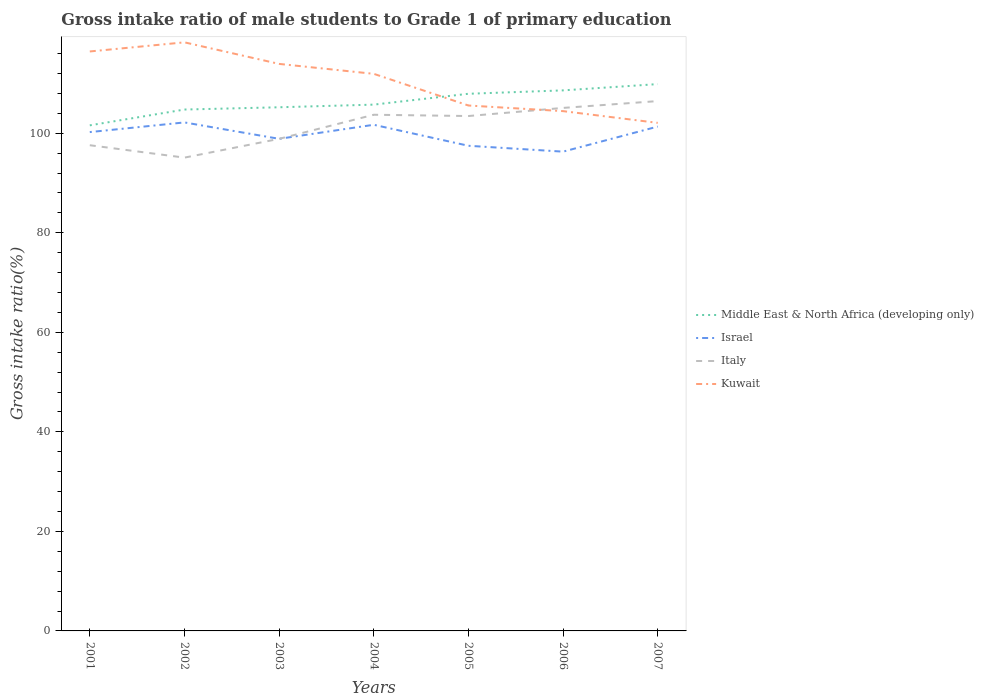How many different coloured lines are there?
Your answer should be very brief. 4. Across all years, what is the maximum gross intake ratio in Middle East & North Africa (developing only)?
Provide a short and direct response. 101.59. What is the total gross intake ratio in Kuwait in the graph?
Offer a terse response. 7.49. What is the difference between the highest and the second highest gross intake ratio in Italy?
Provide a succinct answer. 11.36. Is the gross intake ratio in Italy strictly greater than the gross intake ratio in Middle East & North Africa (developing only) over the years?
Your response must be concise. Yes. What is the difference between two consecutive major ticks on the Y-axis?
Your response must be concise. 20. How many legend labels are there?
Give a very brief answer. 4. How are the legend labels stacked?
Your response must be concise. Vertical. What is the title of the graph?
Keep it short and to the point. Gross intake ratio of male students to Grade 1 of primary education. What is the label or title of the X-axis?
Give a very brief answer. Years. What is the label or title of the Y-axis?
Keep it short and to the point. Gross intake ratio(%). What is the Gross intake ratio(%) in Middle East & North Africa (developing only) in 2001?
Keep it short and to the point. 101.59. What is the Gross intake ratio(%) of Israel in 2001?
Provide a succinct answer. 100.23. What is the Gross intake ratio(%) of Italy in 2001?
Provide a succinct answer. 97.59. What is the Gross intake ratio(%) in Kuwait in 2001?
Ensure brevity in your answer.  116.43. What is the Gross intake ratio(%) of Middle East & North Africa (developing only) in 2002?
Your response must be concise. 104.76. What is the Gross intake ratio(%) in Israel in 2002?
Offer a very short reply. 102.17. What is the Gross intake ratio(%) of Italy in 2002?
Your answer should be very brief. 95.1. What is the Gross intake ratio(%) in Kuwait in 2002?
Your answer should be compact. 118.26. What is the Gross intake ratio(%) of Middle East & North Africa (developing only) in 2003?
Provide a short and direct response. 105.22. What is the Gross intake ratio(%) in Israel in 2003?
Provide a short and direct response. 98.88. What is the Gross intake ratio(%) in Italy in 2003?
Ensure brevity in your answer.  98.87. What is the Gross intake ratio(%) in Kuwait in 2003?
Offer a terse response. 113.93. What is the Gross intake ratio(%) in Middle East & North Africa (developing only) in 2004?
Keep it short and to the point. 105.75. What is the Gross intake ratio(%) of Israel in 2004?
Your answer should be compact. 101.7. What is the Gross intake ratio(%) in Italy in 2004?
Offer a terse response. 103.72. What is the Gross intake ratio(%) in Kuwait in 2004?
Make the answer very short. 111.94. What is the Gross intake ratio(%) of Middle East & North Africa (developing only) in 2005?
Ensure brevity in your answer.  107.93. What is the Gross intake ratio(%) of Israel in 2005?
Give a very brief answer. 97.48. What is the Gross intake ratio(%) of Italy in 2005?
Ensure brevity in your answer.  103.46. What is the Gross intake ratio(%) of Kuwait in 2005?
Ensure brevity in your answer.  105.57. What is the Gross intake ratio(%) of Middle East & North Africa (developing only) in 2006?
Your answer should be very brief. 108.61. What is the Gross intake ratio(%) in Israel in 2006?
Give a very brief answer. 96.3. What is the Gross intake ratio(%) in Italy in 2006?
Your answer should be compact. 105.09. What is the Gross intake ratio(%) in Kuwait in 2006?
Provide a short and direct response. 104.44. What is the Gross intake ratio(%) of Middle East & North Africa (developing only) in 2007?
Keep it short and to the point. 109.87. What is the Gross intake ratio(%) in Israel in 2007?
Your response must be concise. 101.34. What is the Gross intake ratio(%) in Italy in 2007?
Give a very brief answer. 106.46. What is the Gross intake ratio(%) in Kuwait in 2007?
Provide a short and direct response. 102.08. Across all years, what is the maximum Gross intake ratio(%) in Middle East & North Africa (developing only)?
Make the answer very short. 109.87. Across all years, what is the maximum Gross intake ratio(%) in Israel?
Provide a succinct answer. 102.17. Across all years, what is the maximum Gross intake ratio(%) of Italy?
Your answer should be compact. 106.46. Across all years, what is the maximum Gross intake ratio(%) in Kuwait?
Give a very brief answer. 118.26. Across all years, what is the minimum Gross intake ratio(%) in Middle East & North Africa (developing only)?
Your answer should be very brief. 101.59. Across all years, what is the minimum Gross intake ratio(%) in Israel?
Keep it short and to the point. 96.3. Across all years, what is the minimum Gross intake ratio(%) in Italy?
Your answer should be compact. 95.1. Across all years, what is the minimum Gross intake ratio(%) of Kuwait?
Offer a very short reply. 102.08. What is the total Gross intake ratio(%) in Middle East & North Africa (developing only) in the graph?
Keep it short and to the point. 743.73. What is the total Gross intake ratio(%) of Israel in the graph?
Provide a succinct answer. 698.11. What is the total Gross intake ratio(%) in Italy in the graph?
Offer a very short reply. 710.29. What is the total Gross intake ratio(%) of Kuwait in the graph?
Offer a very short reply. 772.67. What is the difference between the Gross intake ratio(%) of Middle East & North Africa (developing only) in 2001 and that in 2002?
Give a very brief answer. -3.18. What is the difference between the Gross intake ratio(%) in Israel in 2001 and that in 2002?
Your response must be concise. -1.94. What is the difference between the Gross intake ratio(%) in Italy in 2001 and that in 2002?
Make the answer very short. 2.49. What is the difference between the Gross intake ratio(%) of Kuwait in 2001 and that in 2002?
Offer a terse response. -1.83. What is the difference between the Gross intake ratio(%) of Middle East & North Africa (developing only) in 2001 and that in 2003?
Provide a short and direct response. -3.63. What is the difference between the Gross intake ratio(%) in Israel in 2001 and that in 2003?
Your response must be concise. 1.35. What is the difference between the Gross intake ratio(%) of Italy in 2001 and that in 2003?
Offer a very short reply. -1.28. What is the difference between the Gross intake ratio(%) of Kuwait in 2001 and that in 2003?
Make the answer very short. 2.5. What is the difference between the Gross intake ratio(%) of Middle East & North Africa (developing only) in 2001 and that in 2004?
Your answer should be very brief. -4.16. What is the difference between the Gross intake ratio(%) of Israel in 2001 and that in 2004?
Offer a terse response. -1.47. What is the difference between the Gross intake ratio(%) of Italy in 2001 and that in 2004?
Make the answer very short. -6.12. What is the difference between the Gross intake ratio(%) of Kuwait in 2001 and that in 2004?
Provide a succinct answer. 4.5. What is the difference between the Gross intake ratio(%) in Middle East & North Africa (developing only) in 2001 and that in 2005?
Your response must be concise. -6.34. What is the difference between the Gross intake ratio(%) of Israel in 2001 and that in 2005?
Provide a succinct answer. 2.75. What is the difference between the Gross intake ratio(%) in Italy in 2001 and that in 2005?
Keep it short and to the point. -5.86. What is the difference between the Gross intake ratio(%) in Kuwait in 2001 and that in 2005?
Offer a very short reply. 10.86. What is the difference between the Gross intake ratio(%) in Middle East & North Africa (developing only) in 2001 and that in 2006?
Ensure brevity in your answer.  -7.03. What is the difference between the Gross intake ratio(%) of Israel in 2001 and that in 2006?
Your response must be concise. 3.93. What is the difference between the Gross intake ratio(%) of Italy in 2001 and that in 2006?
Make the answer very short. -7.5. What is the difference between the Gross intake ratio(%) of Kuwait in 2001 and that in 2006?
Your answer should be compact. 11.99. What is the difference between the Gross intake ratio(%) of Middle East & North Africa (developing only) in 2001 and that in 2007?
Ensure brevity in your answer.  -8.29. What is the difference between the Gross intake ratio(%) of Israel in 2001 and that in 2007?
Make the answer very short. -1.11. What is the difference between the Gross intake ratio(%) of Italy in 2001 and that in 2007?
Provide a succinct answer. -8.87. What is the difference between the Gross intake ratio(%) in Kuwait in 2001 and that in 2007?
Provide a succinct answer. 14.35. What is the difference between the Gross intake ratio(%) in Middle East & North Africa (developing only) in 2002 and that in 2003?
Your answer should be compact. -0.46. What is the difference between the Gross intake ratio(%) in Israel in 2002 and that in 2003?
Give a very brief answer. 3.29. What is the difference between the Gross intake ratio(%) in Italy in 2002 and that in 2003?
Give a very brief answer. -3.77. What is the difference between the Gross intake ratio(%) in Kuwait in 2002 and that in 2003?
Your answer should be compact. 4.33. What is the difference between the Gross intake ratio(%) in Middle East & North Africa (developing only) in 2002 and that in 2004?
Provide a short and direct response. -0.99. What is the difference between the Gross intake ratio(%) in Israel in 2002 and that in 2004?
Keep it short and to the point. 0.47. What is the difference between the Gross intake ratio(%) of Italy in 2002 and that in 2004?
Offer a terse response. -8.62. What is the difference between the Gross intake ratio(%) of Kuwait in 2002 and that in 2004?
Make the answer very short. 6.33. What is the difference between the Gross intake ratio(%) in Middle East & North Africa (developing only) in 2002 and that in 2005?
Ensure brevity in your answer.  -3.17. What is the difference between the Gross intake ratio(%) of Israel in 2002 and that in 2005?
Provide a succinct answer. 4.69. What is the difference between the Gross intake ratio(%) of Italy in 2002 and that in 2005?
Keep it short and to the point. -8.36. What is the difference between the Gross intake ratio(%) in Kuwait in 2002 and that in 2005?
Your answer should be compact. 12.69. What is the difference between the Gross intake ratio(%) in Middle East & North Africa (developing only) in 2002 and that in 2006?
Provide a short and direct response. -3.85. What is the difference between the Gross intake ratio(%) in Israel in 2002 and that in 2006?
Your response must be concise. 5.87. What is the difference between the Gross intake ratio(%) in Italy in 2002 and that in 2006?
Ensure brevity in your answer.  -9.99. What is the difference between the Gross intake ratio(%) of Kuwait in 2002 and that in 2006?
Make the answer very short. 13.82. What is the difference between the Gross intake ratio(%) in Middle East & North Africa (developing only) in 2002 and that in 2007?
Give a very brief answer. -5.11. What is the difference between the Gross intake ratio(%) of Israel in 2002 and that in 2007?
Ensure brevity in your answer.  0.83. What is the difference between the Gross intake ratio(%) of Italy in 2002 and that in 2007?
Provide a short and direct response. -11.36. What is the difference between the Gross intake ratio(%) in Kuwait in 2002 and that in 2007?
Ensure brevity in your answer.  16.18. What is the difference between the Gross intake ratio(%) in Middle East & North Africa (developing only) in 2003 and that in 2004?
Your answer should be very brief. -0.53. What is the difference between the Gross intake ratio(%) of Israel in 2003 and that in 2004?
Your answer should be compact. -2.82. What is the difference between the Gross intake ratio(%) of Italy in 2003 and that in 2004?
Offer a terse response. -4.84. What is the difference between the Gross intake ratio(%) in Kuwait in 2003 and that in 2004?
Offer a very short reply. 2. What is the difference between the Gross intake ratio(%) in Middle East & North Africa (developing only) in 2003 and that in 2005?
Your response must be concise. -2.71. What is the difference between the Gross intake ratio(%) of Israel in 2003 and that in 2005?
Your answer should be compact. 1.4. What is the difference between the Gross intake ratio(%) of Italy in 2003 and that in 2005?
Provide a short and direct response. -4.59. What is the difference between the Gross intake ratio(%) in Kuwait in 2003 and that in 2005?
Provide a succinct answer. 8.36. What is the difference between the Gross intake ratio(%) of Middle East & North Africa (developing only) in 2003 and that in 2006?
Give a very brief answer. -3.39. What is the difference between the Gross intake ratio(%) of Israel in 2003 and that in 2006?
Your answer should be very brief. 2.58. What is the difference between the Gross intake ratio(%) in Italy in 2003 and that in 2006?
Keep it short and to the point. -6.22. What is the difference between the Gross intake ratio(%) of Kuwait in 2003 and that in 2006?
Ensure brevity in your answer.  9.49. What is the difference between the Gross intake ratio(%) in Middle East & North Africa (developing only) in 2003 and that in 2007?
Provide a succinct answer. -4.66. What is the difference between the Gross intake ratio(%) of Israel in 2003 and that in 2007?
Your answer should be compact. -2.46. What is the difference between the Gross intake ratio(%) of Italy in 2003 and that in 2007?
Your answer should be very brief. -7.59. What is the difference between the Gross intake ratio(%) in Kuwait in 2003 and that in 2007?
Provide a succinct answer. 11.85. What is the difference between the Gross intake ratio(%) of Middle East & North Africa (developing only) in 2004 and that in 2005?
Give a very brief answer. -2.18. What is the difference between the Gross intake ratio(%) in Israel in 2004 and that in 2005?
Your response must be concise. 4.22. What is the difference between the Gross intake ratio(%) in Italy in 2004 and that in 2005?
Give a very brief answer. 0.26. What is the difference between the Gross intake ratio(%) in Kuwait in 2004 and that in 2005?
Offer a terse response. 6.36. What is the difference between the Gross intake ratio(%) of Middle East & North Africa (developing only) in 2004 and that in 2006?
Offer a very short reply. -2.86. What is the difference between the Gross intake ratio(%) of Israel in 2004 and that in 2006?
Offer a terse response. 5.4. What is the difference between the Gross intake ratio(%) in Italy in 2004 and that in 2006?
Make the answer very short. -1.37. What is the difference between the Gross intake ratio(%) of Kuwait in 2004 and that in 2006?
Provide a succinct answer. 7.49. What is the difference between the Gross intake ratio(%) of Middle East & North Africa (developing only) in 2004 and that in 2007?
Provide a succinct answer. -4.12. What is the difference between the Gross intake ratio(%) of Israel in 2004 and that in 2007?
Your answer should be very brief. 0.36. What is the difference between the Gross intake ratio(%) in Italy in 2004 and that in 2007?
Keep it short and to the point. -2.75. What is the difference between the Gross intake ratio(%) of Kuwait in 2004 and that in 2007?
Make the answer very short. 9.85. What is the difference between the Gross intake ratio(%) of Middle East & North Africa (developing only) in 2005 and that in 2006?
Your answer should be very brief. -0.68. What is the difference between the Gross intake ratio(%) of Israel in 2005 and that in 2006?
Keep it short and to the point. 1.18. What is the difference between the Gross intake ratio(%) of Italy in 2005 and that in 2006?
Provide a succinct answer. -1.63. What is the difference between the Gross intake ratio(%) of Kuwait in 2005 and that in 2006?
Make the answer very short. 1.13. What is the difference between the Gross intake ratio(%) in Middle East & North Africa (developing only) in 2005 and that in 2007?
Offer a very short reply. -1.94. What is the difference between the Gross intake ratio(%) of Israel in 2005 and that in 2007?
Make the answer very short. -3.86. What is the difference between the Gross intake ratio(%) of Italy in 2005 and that in 2007?
Your response must be concise. -3. What is the difference between the Gross intake ratio(%) in Kuwait in 2005 and that in 2007?
Ensure brevity in your answer.  3.49. What is the difference between the Gross intake ratio(%) of Middle East & North Africa (developing only) in 2006 and that in 2007?
Provide a short and direct response. -1.26. What is the difference between the Gross intake ratio(%) in Israel in 2006 and that in 2007?
Keep it short and to the point. -5.04. What is the difference between the Gross intake ratio(%) of Italy in 2006 and that in 2007?
Offer a terse response. -1.37. What is the difference between the Gross intake ratio(%) of Kuwait in 2006 and that in 2007?
Provide a short and direct response. 2.36. What is the difference between the Gross intake ratio(%) of Middle East & North Africa (developing only) in 2001 and the Gross intake ratio(%) of Israel in 2002?
Your answer should be compact. -0.59. What is the difference between the Gross intake ratio(%) of Middle East & North Africa (developing only) in 2001 and the Gross intake ratio(%) of Italy in 2002?
Provide a succinct answer. 6.49. What is the difference between the Gross intake ratio(%) in Middle East & North Africa (developing only) in 2001 and the Gross intake ratio(%) in Kuwait in 2002?
Your answer should be very brief. -16.68. What is the difference between the Gross intake ratio(%) of Israel in 2001 and the Gross intake ratio(%) of Italy in 2002?
Keep it short and to the point. 5.13. What is the difference between the Gross intake ratio(%) in Israel in 2001 and the Gross intake ratio(%) in Kuwait in 2002?
Offer a very short reply. -18.03. What is the difference between the Gross intake ratio(%) of Italy in 2001 and the Gross intake ratio(%) of Kuwait in 2002?
Your response must be concise. -20.67. What is the difference between the Gross intake ratio(%) in Middle East & North Africa (developing only) in 2001 and the Gross intake ratio(%) in Israel in 2003?
Offer a very short reply. 2.71. What is the difference between the Gross intake ratio(%) of Middle East & North Africa (developing only) in 2001 and the Gross intake ratio(%) of Italy in 2003?
Make the answer very short. 2.72. What is the difference between the Gross intake ratio(%) of Middle East & North Africa (developing only) in 2001 and the Gross intake ratio(%) of Kuwait in 2003?
Your answer should be very brief. -12.35. What is the difference between the Gross intake ratio(%) in Israel in 2001 and the Gross intake ratio(%) in Italy in 2003?
Your response must be concise. 1.36. What is the difference between the Gross intake ratio(%) in Israel in 2001 and the Gross intake ratio(%) in Kuwait in 2003?
Offer a very short reply. -13.7. What is the difference between the Gross intake ratio(%) in Italy in 2001 and the Gross intake ratio(%) in Kuwait in 2003?
Provide a succinct answer. -16.34. What is the difference between the Gross intake ratio(%) of Middle East & North Africa (developing only) in 2001 and the Gross intake ratio(%) of Israel in 2004?
Provide a short and direct response. -0.11. What is the difference between the Gross intake ratio(%) in Middle East & North Africa (developing only) in 2001 and the Gross intake ratio(%) in Italy in 2004?
Provide a succinct answer. -2.13. What is the difference between the Gross intake ratio(%) in Middle East & North Africa (developing only) in 2001 and the Gross intake ratio(%) in Kuwait in 2004?
Your answer should be compact. -10.35. What is the difference between the Gross intake ratio(%) in Israel in 2001 and the Gross intake ratio(%) in Italy in 2004?
Your answer should be compact. -3.48. What is the difference between the Gross intake ratio(%) in Israel in 2001 and the Gross intake ratio(%) in Kuwait in 2004?
Your answer should be very brief. -11.7. What is the difference between the Gross intake ratio(%) in Italy in 2001 and the Gross intake ratio(%) in Kuwait in 2004?
Ensure brevity in your answer.  -14.34. What is the difference between the Gross intake ratio(%) of Middle East & North Africa (developing only) in 2001 and the Gross intake ratio(%) of Israel in 2005?
Make the answer very short. 4.1. What is the difference between the Gross intake ratio(%) of Middle East & North Africa (developing only) in 2001 and the Gross intake ratio(%) of Italy in 2005?
Your answer should be very brief. -1.87. What is the difference between the Gross intake ratio(%) of Middle East & North Africa (developing only) in 2001 and the Gross intake ratio(%) of Kuwait in 2005?
Ensure brevity in your answer.  -3.99. What is the difference between the Gross intake ratio(%) of Israel in 2001 and the Gross intake ratio(%) of Italy in 2005?
Your answer should be compact. -3.23. What is the difference between the Gross intake ratio(%) of Israel in 2001 and the Gross intake ratio(%) of Kuwait in 2005?
Give a very brief answer. -5.34. What is the difference between the Gross intake ratio(%) in Italy in 2001 and the Gross intake ratio(%) in Kuwait in 2005?
Make the answer very short. -7.98. What is the difference between the Gross intake ratio(%) in Middle East & North Africa (developing only) in 2001 and the Gross intake ratio(%) in Israel in 2006?
Your answer should be very brief. 5.29. What is the difference between the Gross intake ratio(%) of Middle East & North Africa (developing only) in 2001 and the Gross intake ratio(%) of Italy in 2006?
Your response must be concise. -3.5. What is the difference between the Gross intake ratio(%) in Middle East & North Africa (developing only) in 2001 and the Gross intake ratio(%) in Kuwait in 2006?
Offer a terse response. -2.85. What is the difference between the Gross intake ratio(%) of Israel in 2001 and the Gross intake ratio(%) of Italy in 2006?
Your answer should be compact. -4.86. What is the difference between the Gross intake ratio(%) of Israel in 2001 and the Gross intake ratio(%) of Kuwait in 2006?
Ensure brevity in your answer.  -4.21. What is the difference between the Gross intake ratio(%) in Italy in 2001 and the Gross intake ratio(%) in Kuwait in 2006?
Offer a terse response. -6.85. What is the difference between the Gross intake ratio(%) in Middle East & North Africa (developing only) in 2001 and the Gross intake ratio(%) in Israel in 2007?
Your answer should be compact. 0.24. What is the difference between the Gross intake ratio(%) in Middle East & North Africa (developing only) in 2001 and the Gross intake ratio(%) in Italy in 2007?
Provide a short and direct response. -4.87. What is the difference between the Gross intake ratio(%) in Middle East & North Africa (developing only) in 2001 and the Gross intake ratio(%) in Kuwait in 2007?
Offer a very short reply. -0.5. What is the difference between the Gross intake ratio(%) in Israel in 2001 and the Gross intake ratio(%) in Italy in 2007?
Your answer should be very brief. -6.23. What is the difference between the Gross intake ratio(%) of Israel in 2001 and the Gross intake ratio(%) of Kuwait in 2007?
Make the answer very short. -1.85. What is the difference between the Gross intake ratio(%) in Italy in 2001 and the Gross intake ratio(%) in Kuwait in 2007?
Give a very brief answer. -4.49. What is the difference between the Gross intake ratio(%) in Middle East & North Africa (developing only) in 2002 and the Gross intake ratio(%) in Israel in 2003?
Offer a very short reply. 5.88. What is the difference between the Gross intake ratio(%) of Middle East & North Africa (developing only) in 2002 and the Gross intake ratio(%) of Italy in 2003?
Make the answer very short. 5.89. What is the difference between the Gross intake ratio(%) of Middle East & North Africa (developing only) in 2002 and the Gross intake ratio(%) of Kuwait in 2003?
Provide a succinct answer. -9.17. What is the difference between the Gross intake ratio(%) of Israel in 2002 and the Gross intake ratio(%) of Italy in 2003?
Give a very brief answer. 3.3. What is the difference between the Gross intake ratio(%) of Israel in 2002 and the Gross intake ratio(%) of Kuwait in 2003?
Offer a very short reply. -11.76. What is the difference between the Gross intake ratio(%) of Italy in 2002 and the Gross intake ratio(%) of Kuwait in 2003?
Ensure brevity in your answer.  -18.83. What is the difference between the Gross intake ratio(%) in Middle East & North Africa (developing only) in 2002 and the Gross intake ratio(%) in Israel in 2004?
Offer a very short reply. 3.06. What is the difference between the Gross intake ratio(%) of Middle East & North Africa (developing only) in 2002 and the Gross intake ratio(%) of Italy in 2004?
Your answer should be very brief. 1.05. What is the difference between the Gross intake ratio(%) of Middle East & North Africa (developing only) in 2002 and the Gross intake ratio(%) of Kuwait in 2004?
Give a very brief answer. -7.17. What is the difference between the Gross intake ratio(%) in Israel in 2002 and the Gross intake ratio(%) in Italy in 2004?
Ensure brevity in your answer.  -1.54. What is the difference between the Gross intake ratio(%) in Israel in 2002 and the Gross intake ratio(%) in Kuwait in 2004?
Provide a short and direct response. -9.76. What is the difference between the Gross intake ratio(%) in Italy in 2002 and the Gross intake ratio(%) in Kuwait in 2004?
Provide a succinct answer. -16.84. What is the difference between the Gross intake ratio(%) in Middle East & North Africa (developing only) in 2002 and the Gross intake ratio(%) in Israel in 2005?
Ensure brevity in your answer.  7.28. What is the difference between the Gross intake ratio(%) of Middle East & North Africa (developing only) in 2002 and the Gross intake ratio(%) of Italy in 2005?
Make the answer very short. 1.31. What is the difference between the Gross intake ratio(%) of Middle East & North Africa (developing only) in 2002 and the Gross intake ratio(%) of Kuwait in 2005?
Your answer should be compact. -0.81. What is the difference between the Gross intake ratio(%) of Israel in 2002 and the Gross intake ratio(%) of Italy in 2005?
Your answer should be very brief. -1.28. What is the difference between the Gross intake ratio(%) of Israel in 2002 and the Gross intake ratio(%) of Kuwait in 2005?
Keep it short and to the point. -3.4. What is the difference between the Gross intake ratio(%) of Italy in 2002 and the Gross intake ratio(%) of Kuwait in 2005?
Keep it short and to the point. -10.47. What is the difference between the Gross intake ratio(%) in Middle East & North Africa (developing only) in 2002 and the Gross intake ratio(%) in Israel in 2006?
Offer a very short reply. 8.46. What is the difference between the Gross intake ratio(%) of Middle East & North Africa (developing only) in 2002 and the Gross intake ratio(%) of Italy in 2006?
Provide a succinct answer. -0.33. What is the difference between the Gross intake ratio(%) in Middle East & North Africa (developing only) in 2002 and the Gross intake ratio(%) in Kuwait in 2006?
Your response must be concise. 0.32. What is the difference between the Gross intake ratio(%) in Israel in 2002 and the Gross intake ratio(%) in Italy in 2006?
Offer a terse response. -2.92. What is the difference between the Gross intake ratio(%) in Israel in 2002 and the Gross intake ratio(%) in Kuwait in 2006?
Provide a short and direct response. -2.27. What is the difference between the Gross intake ratio(%) of Italy in 2002 and the Gross intake ratio(%) of Kuwait in 2006?
Offer a terse response. -9.34. What is the difference between the Gross intake ratio(%) in Middle East & North Africa (developing only) in 2002 and the Gross intake ratio(%) in Israel in 2007?
Provide a short and direct response. 3.42. What is the difference between the Gross intake ratio(%) of Middle East & North Africa (developing only) in 2002 and the Gross intake ratio(%) of Italy in 2007?
Provide a succinct answer. -1.7. What is the difference between the Gross intake ratio(%) of Middle East & North Africa (developing only) in 2002 and the Gross intake ratio(%) of Kuwait in 2007?
Ensure brevity in your answer.  2.68. What is the difference between the Gross intake ratio(%) of Israel in 2002 and the Gross intake ratio(%) of Italy in 2007?
Keep it short and to the point. -4.29. What is the difference between the Gross intake ratio(%) of Israel in 2002 and the Gross intake ratio(%) of Kuwait in 2007?
Make the answer very short. 0.09. What is the difference between the Gross intake ratio(%) of Italy in 2002 and the Gross intake ratio(%) of Kuwait in 2007?
Provide a succinct answer. -6.98. What is the difference between the Gross intake ratio(%) in Middle East & North Africa (developing only) in 2003 and the Gross intake ratio(%) in Israel in 2004?
Your answer should be compact. 3.52. What is the difference between the Gross intake ratio(%) of Middle East & North Africa (developing only) in 2003 and the Gross intake ratio(%) of Italy in 2004?
Offer a terse response. 1.5. What is the difference between the Gross intake ratio(%) in Middle East & North Africa (developing only) in 2003 and the Gross intake ratio(%) in Kuwait in 2004?
Keep it short and to the point. -6.72. What is the difference between the Gross intake ratio(%) of Israel in 2003 and the Gross intake ratio(%) of Italy in 2004?
Ensure brevity in your answer.  -4.84. What is the difference between the Gross intake ratio(%) of Israel in 2003 and the Gross intake ratio(%) of Kuwait in 2004?
Provide a succinct answer. -13.06. What is the difference between the Gross intake ratio(%) in Italy in 2003 and the Gross intake ratio(%) in Kuwait in 2004?
Keep it short and to the point. -13.06. What is the difference between the Gross intake ratio(%) of Middle East & North Africa (developing only) in 2003 and the Gross intake ratio(%) of Israel in 2005?
Offer a terse response. 7.74. What is the difference between the Gross intake ratio(%) in Middle East & North Africa (developing only) in 2003 and the Gross intake ratio(%) in Italy in 2005?
Give a very brief answer. 1.76. What is the difference between the Gross intake ratio(%) in Middle East & North Africa (developing only) in 2003 and the Gross intake ratio(%) in Kuwait in 2005?
Ensure brevity in your answer.  -0.36. What is the difference between the Gross intake ratio(%) in Israel in 2003 and the Gross intake ratio(%) in Italy in 2005?
Keep it short and to the point. -4.58. What is the difference between the Gross intake ratio(%) of Israel in 2003 and the Gross intake ratio(%) of Kuwait in 2005?
Give a very brief answer. -6.69. What is the difference between the Gross intake ratio(%) of Italy in 2003 and the Gross intake ratio(%) of Kuwait in 2005?
Ensure brevity in your answer.  -6.7. What is the difference between the Gross intake ratio(%) in Middle East & North Africa (developing only) in 2003 and the Gross intake ratio(%) in Israel in 2006?
Ensure brevity in your answer.  8.92. What is the difference between the Gross intake ratio(%) in Middle East & North Africa (developing only) in 2003 and the Gross intake ratio(%) in Italy in 2006?
Keep it short and to the point. 0.13. What is the difference between the Gross intake ratio(%) of Middle East & North Africa (developing only) in 2003 and the Gross intake ratio(%) of Kuwait in 2006?
Offer a very short reply. 0.78. What is the difference between the Gross intake ratio(%) of Israel in 2003 and the Gross intake ratio(%) of Italy in 2006?
Your answer should be very brief. -6.21. What is the difference between the Gross intake ratio(%) of Israel in 2003 and the Gross intake ratio(%) of Kuwait in 2006?
Offer a very short reply. -5.56. What is the difference between the Gross intake ratio(%) of Italy in 2003 and the Gross intake ratio(%) of Kuwait in 2006?
Your answer should be very brief. -5.57. What is the difference between the Gross intake ratio(%) of Middle East & North Africa (developing only) in 2003 and the Gross intake ratio(%) of Israel in 2007?
Your answer should be compact. 3.87. What is the difference between the Gross intake ratio(%) in Middle East & North Africa (developing only) in 2003 and the Gross intake ratio(%) in Italy in 2007?
Offer a very short reply. -1.24. What is the difference between the Gross intake ratio(%) in Middle East & North Africa (developing only) in 2003 and the Gross intake ratio(%) in Kuwait in 2007?
Your response must be concise. 3.13. What is the difference between the Gross intake ratio(%) in Israel in 2003 and the Gross intake ratio(%) in Italy in 2007?
Your response must be concise. -7.58. What is the difference between the Gross intake ratio(%) in Israel in 2003 and the Gross intake ratio(%) in Kuwait in 2007?
Make the answer very short. -3.21. What is the difference between the Gross intake ratio(%) in Italy in 2003 and the Gross intake ratio(%) in Kuwait in 2007?
Your response must be concise. -3.21. What is the difference between the Gross intake ratio(%) in Middle East & North Africa (developing only) in 2004 and the Gross intake ratio(%) in Israel in 2005?
Provide a succinct answer. 8.27. What is the difference between the Gross intake ratio(%) of Middle East & North Africa (developing only) in 2004 and the Gross intake ratio(%) of Italy in 2005?
Provide a succinct answer. 2.29. What is the difference between the Gross intake ratio(%) in Middle East & North Africa (developing only) in 2004 and the Gross intake ratio(%) in Kuwait in 2005?
Your answer should be compact. 0.18. What is the difference between the Gross intake ratio(%) in Israel in 2004 and the Gross intake ratio(%) in Italy in 2005?
Keep it short and to the point. -1.76. What is the difference between the Gross intake ratio(%) of Israel in 2004 and the Gross intake ratio(%) of Kuwait in 2005?
Offer a terse response. -3.87. What is the difference between the Gross intake ratio(%) of Italy in 2004 and the Gross intake ratio(%) of Kuwait in 2005?
Your answer should be very brief. -1.86. What is the difference between the Gross intake ratio(%) in Middle East & North Africa (developing only) in 2004 and the Gross intake ratio(%) in Israel in 2006?
Offer a terse response. 9.45. What is the difference between the Gross intake ratio(%) of Middle East & North Africa (developing only) in 2004 and the Gross intake ratio(%) of Italy in 2006?
Your answer should be compact. 0.66. What is the difference between the Gross intake ratio(%) of Middle East & North Africa (developing only) in 2004 and the Gross intake ratio(%) of Kuwait in 2006?
Keep it short and to the point. 1.31. What is the difference between the Gross intake ratio(%) of Israel in 2004 and the Gross intake ratio(%) of Italy in 2006?
Give a very brief answer. -3.39. What is the difference between the Gross intake ratio(%) in Israel in 2004 and the Gross intake ratio(%) in Kuwait in 2006?
Your response must be concise. -2.74. What is the difference between the Gross intake ratio(%) of Italy in 2004 and the Gross intake ratio(%) of Kuwait in 2006?
Ensure brevity in your answer.  -0.73. What is the difference between the Gross intake ratio(%) in Middle East & North Africa (developing only) in 2004 and the Gross intake ratio(%) in Israel in 2007?
Give a very brief answer. 4.41. What is the difference between the Gross intake ratio(%) of Middle East & North Africa (developing only) in 2004 and the Gross intake ratio(%) of Italy in 2007?
Your answer should be very brief. -0.71. What is the difference between the Gross intake ratio(%) of Middle East & North Africa (developing only) in 2004 and the Gross intake ratio(%) of Kuwait in 2007?
Provide a succinct answer. 3.67. What is the difference between the Gross intake ratio(%) of Israel in 2004 and the Gross intake ratio(%) of Italy in 2007?
Your answer should be very brief. -4.76. What is the difference between the Gross intake ratio(%) in Israel in 2004 and the Gross intake ratio(%) in Kuwait in 2007?
Your response must be concise. -0.38. What is the difference between the Gross intake ratio(%) of Italy in 2004 and the Gross intake ratio(%) of Kuwait in 2007?
Give a very brief answer. 1.63. What is the difference between the Gross intake ratio(%) in Middle East & North Africa (developing only) in 2005 and the Gross intake ratio(%) in Israel in 2006?
Provide a succinct answer. 11.63. What is the difference between the Gross intake ratio(%) of Middle East & North Africa (developing only) in 2005 and the Gross intake ratio(%) of Italy in 2006?
Your answer should be very brief. 2.84. What is the difference between the Gross intake ratio(%) in Middle East & North Africa (developing only) in 2005 and the Gross intake ratio(%) in Kuwait in 2006?
Ensure brevity in your answer.  3.49. What is the difference between the Gross intake ratio(%) of Israel in 2005 and the Gross intake ratio(%) of Italy in 2006?
Your answer should be compact. -7.61. What is the difference between the Gross intake ratio(%) of Israel in 2005 and the Gross intake ratio(%) of Kuwait in 2006?
Your response must be concise. -6.96. What is the difference between the Gross intake ratio(%) of Italy in 2005 and the Gross intake ratio(%) of Kuwait in 2006?
Make the answer very short. -0.98. What is the difference between the Gross intake ratio(%) of Middle East & North Africa (developing only) in 2005 and the Gross intake ratio(%) of Israel in 2007?
Make the answer very short. 6.59. What is the difference between the Gross intake ratio(%) of Middle East & North Africa (developing only) in 2005 and the Gross intake ratio(%) of Italy in 2007?
Keep it short and to the point. 1.47. What is the difference between the Gross intake ratio(%) in Middle East & North Africa (developing only) in 2005 and the Gross intake ratio(%) in Kuwait in 2007?
Your response must be concise. 5.85. What is the difference between the Gross intake ratio(%) of Israel in 2005 and the Gross intake ratio(%) of Italy in 2007?
Your response must be concise. -8.98. What is the difference between the Gross intake ratio(%) of Israel in 2005 and the Gross intake ratio(%) of Kuwait in 2007?
Ensure brevity in your answer.  -4.6. What is the difference between the Gross intake ratio(%) in Italy in 2005 and the Gross intake ratio(%) in Kuwait in 2007?
Your answer should be compact. 1.37. What is the difference between the Gross intake ratio(%) of Middle East & North Africa (developing only) in 2006 and the Gross intake ratio(%) of Israel in 2007?
Make the answer very short. 7.27. What is the difference between the Gross intake ratio(%) of Middle East & North Africa (developing only) in 2006 and the Gross intake ratio(%) of Italy in 2007?
Your answer should be compact. 2.15. What is the difference between the Gross intake ratio(%) in Middle East & North Africa (developing only) in 2006 and the Gross intake ratio(%) in Kuwait in 2007?
Your answer should be compact. 6.53. What is the difference between the Gross intake ratio(%) of Israel in 2006 and the Gross intake ratio(%) of Italy in 2007?
Offer a very short reply. -10.16. What is the difference between the Gross intake ratio(%) in Israel in 2006 and the Gross intake ratio(%) in Kuwait in 2007?
Offer a very short reply. -5.78. What is the difference between the Gross intake ratio(%) of Italy in 2006 and the Gross intake ratio(%) of Kuwait in 2007?
Your answer should be compact. 3.01. What is the average Gross intake ratio(%) in Middle East & North Africa (developing only) per year?
Make the answer very short. 106.25. What is the average Gross intake ratio(%) in Israel per year?
Offer a very short reply. 99.73. What is the average Gross intake ratio(%) of Italy per year?
Ensure brevity in your answer.  101.47. What is the average Gross intake ratio(%) of Kuwait per year?
Offer a terse response. 110.38. In the year 2001, what is the difference between the Gross intake ratio(%) of Middle East & North Africa (developing only) and Gross intake ratio(%) of Israel?
Offer a very short reply. 1.36. In the year 2001, what is the difference between the Gross intake ratio(%) of Middle East & North Africa (developing only) and Gross intake ratio(%) of Italy?
Your answer should be compact. 3.99. In the year 2001, what is the difference between the Gross intake ratio(%) in Middle East & North Africa (developing only) and Gross intake ratio(%) in Kuwait?
Your answer should be compact. -14.85. In the year 2001, what is the difference between the Gross intake ratio(%) of Israel and Gross intake ratio(%) of Italy?
Offer a very short reply. 2.64. In the year 2001, what is the difference between the Gross intake ratio(%) in Israel and Gross intake ratio(%) in Kuwait?
Give a very brief answer. -16.2. In the year 2001, what is the difference between the Gross intake ratio(%) of Italy and Gross intake ratio(%) of Kuwait?
Keep it short and to the point. -18.84. In the year 2002, what is the difference between the Gross intake ratio(%) of Middle East & North Africa (developing only) and Gross intake ratio(%) of Israel?
Provide a succinct answer. 2.59. In the year 2002, what is the difference between the Gross intake ratio(%) in Middle East & North Africa (developing only) and Gross intake ratio(%) in Italy?
Your answer should be very brief. 9.66. In the year 2002, what is the difference between the Gross intake ratio(%) of Middle East & North Africa (developing only) and Gross intake ratio(%) of Kuwait?
Give a very brief answer. -13.5. In the year 2002, what is the difference between the Gross intake ratio(%) of Israel and Gross intake ratio(%) of Italy?
Offer a terse response. 7.07. In the year 2002, what is the difference between the Gross intake ratio(%) in Israel and Gross intake ratio(%) in Kuwait?
Provide a short and direct response. -16.09. In the year 2002, what is the difference between the Gross intake ratio(%) in Italy and Gross intake ratio(%) in Kuwait?
Keep it short and to the point. -23.16. In the year 2003, what is the difference between the Gross intake ratio(%) in Middle East & North Africa (developing only) and Gross intake ratio(%) in Israel?
Offer a very short reply. 6.34. In the year 2003, what is the difference between the Gross intake ratio(%) in Middle East & North Africa (developing only) and Gross intake ratio(%) in Italy?
Your response must be concise. 6.35. In the year 2003, what is the difference between the Gross intake ratio(%) of Middle East & North Africa (developing only) and Gross intake ratio(%) of Kuwait?
Offer a terse response. -8.72. In the year 2003, what is the difference between the Gross intake ratio(%) in Israel and Gross intake ratio(%) in Italy?
Your answer should be very brief. 0.01. In the year 2003, what is the difference between the Gross intake ratio(%) in Israel and Gross intake ratio(%) in Kuwait?
Provide a short and direct response. -15.05. In the year 2003, what is the difference between the Gross intake ratio(%) of Italy and Gross intake ratio(%) of Kuwait?
Offer a terse response. -15.06. In the year 2004, what is the difference between the Gross intake ratio(%) of Middle East & North Africa (developing only) and Gross intake ratio(%) of Israel?
Provide a succinct answer. 4.05. In the year 2004, what is the difference between the Gross intake ratio(%) of Middle East & North Africa (developing only) and Gross intake ratio(%) of Italy?
Ensure brevity in your answer.  2.03. In the year 2004, what is the difference between the Gross intake ratio(%) in Middle East & North Africa (developing only) and Gross intake ratio(%) in Kuwait?
Your answer should be very brief. -6.19. In the year 2004, what is the difference between the Gross intake ratio(%) in Israel and Gross intake ratio(%) in Italy?
Your answer should be very brief. -2.02. In the year 2004, what is the difference between the Gross intake ratio(%) of Israel and Gross intake ratio(%) of Kuwait?
Keep it short and to the point. -10.24. In the year 2004, what is the difference between the Gross intake ratio(%) of Italy and Gross intake ratio(%) of Kuwait?
Provide a succinct answer. -8.22. In the year 2005, what is the difference between the Gross intake ratio(%) in Middle East & North Africa (developing only) and Gross intake ratio(%) in Israel?
Keep it short and to the point. 10.45. In the year 2005, what is the difference between the Gross intake ratio(%) of Middle East & North Africa (developing only) and Gross intake ratio(%) of Italy?
Offer a terse response. 4.47. In the year 2005, what is the difference between the Gross intake ratio(%) in Middle East & North Africa (developing only) and Gross intake ratio(%) in Kuwait?
Give a very brief answer. 2.36. In the year 2005, what is the difference between the Gross intake ratio(%) in Israel and Gross intake ratio(%) in Italy?
Your response must be concise. -5.97. In the year 2005, what is the difference between the Gross intake ratio(%) of Israel and Gross intake ratio(%) of Kuwait?
Your answer should be compact. -8.09. In the year 2005, what is the difference between the Gross intake ratio(%) of Italy and Gross intake ratio(%) of Kuwait?
Make the answer very short. -2.12. In the year 2006, what is the difference between the Gross intake ratio(%) of Middle East & North Africa (developing only) and Gross intake ratio(%) of Israel?
Your answer should be very brief. 12.31. In the year 2006, what is the difference between the Gross intake ratio(%) of Middle East & North Africa (developing only) and Gross intake ratio(%) of Italy?
Offer a very short reply. 3.52. In the year 2006, what is the difference between the Gross intake ratio(%) of Middle East & North Africa (developing only) and Gross intake ratio(%) of Kuwait?
Your answer should be very brief. 4.17. In the year 2006, what is the difference between the Gross intake ratio(%) of Israel and Gross intake ratio(%) of Italy?
Give a very brief answer. -8.79. In the year 2006, what is the difference between the Gross intake ratio(%) in Israel and Gross intake ratio(%) in Kuwait?
Ensure brevity in your answer.  -8.14. In the year 2006, what is the difference between the Gross intake ratio(%) of Italy and Gross intake ratio(%) of Kuwait?
Provide a short and direct response. 0.65. In the year 2007, what is the difference between the Gross intake ratio(%) in Middle East & North Africa (developing only) and Gross intake ratio(%) in Israel?
Ensure brevity in your answer.  8.53. In the year 2007, what is the difference between the Gross intake ratio(%) in Middle East & North Africa (developing only) and Gross intake ratio(%) in Italy?
Give a very brief answer. 3.41. In the year 2007, what is the difference between the Gross intake ratio(%) in Middle East & North Africa (developing only) and Gross intake ratio(%) in Kuwait?
Provide a succinct answer. 7.79. In the year 2007, what is the difference between the Gross intake ratio(%) in Israel and Gross intake ratio(%) in Italy?
Keep it short and to the point. -5.12. In the year 2007, what is the difference between the Gross intake ratio(%) of Israel and Gross intake ratio(%) of Kuwait?
Your response must be concise. -0.74. In the year 2007, what is the difference between the Gross intake ratio(%) of Italy and Gross intake ratio(%) of Kuwait?
Provide a succinct answer. 4.38. What is the ratio of the Gross intake ratio(%) of Middle East & North Africa (developing only) in 2001 to that in 2002?
Provide a succinct answer. 0.97. What is the ratio of the Gross intake ratio(%) in Italy in 2001 to that in 2002?
Your answer should be compact. 1.03. What is the ratio of the Gross intake ratio(%) in Kuwait in 2001 to that in 2002?
Ensure brevity in your answer.  0.98. What is the ratio of the Gross intake ratio(%) in Middle East & North Africa (developing only) in 2001 to that in 2003?
Ensure brevity in your answer.  0.97. What is the ratio of the Gross intake ratio(%) of Israel in 2001 to that in 2003?
Offer a very short reply. 1.01. What is the ratio of the Gross intake ratio(%) in Italy in 2001 to that in 2003?
Offer a terse response. 0.99. What is the ratio of the Gross intake ratio(%) of Kuwait in 2001 to that in 2003?
Offer a terse response. 1.02. What is the ratio of the Gross intake ratio(%) of Middle East & North Africa (developing only) in 2001 to that in 2004?
Make the answer very short. 0.96. What is the ratio of the Gross intake ratio(%) of Israel in 2001 to that in 2004?
Offer a very short reply. 0.99. What is the ratio of the Gross intake ratio(%) in Italy in 2001 to that in 2004?
Your response must be concise. 0.94. What is the ratio of the Gross intake ratio(%) in Kuwait in 2001 to that in 2004?
Provide a short and direct response. 1.04. What is the ratio of the Gross intake ratio(%) in Israel in 2001 to that in 2005?
Your response must be concise. 1.03. What is the ratio of the Gross intake ratio(%) of Italy in 2001 to that in 2005?
Keep it short and to the point. 0.94. What is the ratio of the Gross intake ratio(%) of Kuwait in 2001 to that in 2005?
Make the answer very short. 1.1. What is the ratio of the Gross intake ratio(%) of Middle East & North Africa (developing only) in 2001 to that in 2006?
Provide a succinct answer. 0.94. What is the ratio of the Gross intake ratio(%) of Israel in 2001 to that in 2006?
Your response must be concise. 1.04. What is the ratio of the Gross intake ratio(%) in Italy in 2001 to that in 2006?
Ensure brevity in your answer.  0.93. What is the ratio of the Gross intake ratio(%) in Kuwait in 2001 to that in 2006?
Your answer should be very brief. 1.11. What is the ratio of the Gross intake ratio(%) in Middle East & North Africa (developing only) in 2001 to that in 2007?
Provide a succinct answer. 0.92. What is the ratio of the Gross intake ratio(%) in Israel in 2001 to that in 2007?
Provide a succinct answer. 0.99. What is the ratio of the Gross intake ratio(%) of Italy in 2001 to that in 2007?
Your answer should be very brief. 0.92. What is the ratio of the Gross intake ratio(%) in Kuwait in 2001 to that in 2007?
Give a very brief answer. 1.14. What is the ratio of the Gross intake ratio(%) of Middle East & North Africa (developing only) in 2002 to that in 2003?
Offer a terse response. 1. What is the ratio of the Gross intake ratio(%) in Israel in 2002 to that in 2003?
Keep it short and to the point. 1.03. What is the ratio of the Gross intake ratio(%) in Italy in 2002 to that in 2003?
Your response must be concise. 0.96. What is the ratio of the Gross intake ratio(%) in Kuwait in 2002 to that in 2003?
Provide a short and direct response. 1.04. What is the ratio of the Gross intake ratio(%) of Middle East & North Africa (developing only) in 2002 to that in 2004?
Provide a short and direct response. 0.99. What is the ratio of the Gross intake ratio(%) of Israel in 2002 to that in 2004?
Keep it short and to the point. 1. What is the ratio of the Gross intake ratio(%) of Italy in 2002 to that in 2004?
Your answer should be compact. 0.92. What is the ratio of the Gross intake ratio(%) of Kuwait in 2002 to that in 2004?
Your response must be concise. 1.06. What is the ratio of the Gross intake ratio(%) in Middle East & North Africa (developing only) in 2002 to that in 2005?
Provide a short and direct response. 0.97. What is the ratio of the Gross intake ratio(%) in Israel in 2002 to that in 2005?
Give a very brief answer. 1.05. What is the ratio of the Gross intake ratio(%) of Italy in 2002 to that in 2005?
Your answer should be very brief. 0.92. What is the ratio of the Gross intake ratio(%) of Kuwait in 2002 to that in 2005?
Offer a terse response. 1.12. What is the ratio of the Gross intake ratio(%) of Middle East & North Africa (developing only) in 2002 to that in 2006?
Keep it short and to the point. 0.96. What is the ratio of the Gross intake ratio(%) of Israel in 2002 to that in 2006?
Your answer should be compact. 1.06. What is the ratio of the Gross intake ratio(%) of Italy in 2002 to that in 2006?
Provide a succinct answer. 0.9. What is the ratio of the Gross intake ratio(%) of Kuwait in 2002 to that in 2006?
Give a very brief answer. 1.13. What is the ratio of the Gross intake ratio(%) of Middle East & North Africa (developing only) in 2002 to that in 2007?
Provide a succinct answer. 0.95. What is the ratio of the Gross intake ratio(%) in Israel in 2002 to that in 2007?
Offer a terse response. 1.01. What is the ratio of the Gross intake ratio(%) in Italy in 2002 to that in 2007?
Provide a short and direct response. 0.89. What is the ratio of the Gross intake ratio(%) of Kuwait in 2002 to that in 2007?
Your answer should be compact. 1.16. What is the ratio of the Gross intake ratio(%) in Israel in 2003 to that in 2004?
Keep it short and to the point. 0.97. What is the ratio of the Gross intake ratio(%) in Italy in 2003 to that in 2004?
Give a very brief answer. 0.95. What is the ratio of the Gross intake ratio(%) of Kuwait in 2003 to that in 2004?
Your answer should be compact. 1.02. What is the ratio of the Gross intake ratio(%) of Middle East & North Africa (developing only) in 2003 to that in 2005?
Your response must be concise. 0.97. What is the ratio of the Gross intake ratio(%) of Israel in 2003 to that in 2005?
Give a very brief answer. 1.01. What is the ratio of the Gross intake ratio(%) of Italy in 2003 to that in 2005?
Ensure brevity in your answer.  0.96. What is the ratio of the Gross intake ratio(%) of Kuwait in 2003 to that in 2005?
Provide a short and direct response. 1.08. What is the ratio of the Gross intake ratio(%) in Middle East & North Africa (developing only) in 2003 to that in 2006?
Offer a terse response. 0.97. What is the ratio of the Gross intake ratio(%) of Israel in 2003 to that in 2006?
Offer a very short reply. 1.03. What is the ratio of the Gross intake ratio(%) of Italy in 2003 to that in 2006?
Keep it short and to the point. 0.94. What is the ratio of the Gross intake ratio(%) in Kuwait in 2003 to that in 2006?
Your answer should be very brief. 1.09. What is the ratio of the Gross intake ratio(%) in Middle East & North Africa (developing only) in 2003 to that in 2007?
Your answer should be very brief. 0.96. What is the ratio of the Gross intake ratio(%) in Israel in 2003 to that in 2007?
Keep it short and to the point. 0.98. What is the ratio of the Gross intake ratio(%) in Italy in 2003 to that in 2007?
Provide a succinct answer. 0.93. What is the ratio of the Gross intake ratio(%) in Kuwait in 2003 to that in 2007?
Your response must be concise. 1.12. What is the ratio of the Gross intake ratio(%) of Middle East & North Africa (developing only) in 2004 to that in 2005?
Your answer should be compact. 0.98. What is the ratio of the Gross intake ratio(%) of Israel in 2004 to that in 2005?
Make the answer very short. 1.04. What is the ratio of the Gross intake ratio(%) of Italy in 2004 to that in 2005?
Ensure brevity in your answer.  1. What is the ratio of the Gross intake ratio(%) in Kuwait in 2004 to that in 2005?
Your answer should be compact. 1.06. What is the ratio of the Gross intake ratio(%) of Middle East & North Africa (developing only) in 2004 to that in 2006?
Keep it short and to the point. 0.97. What is the ratio of the Gross intake ratio(%) of Israel in 2004 to that in 2006?
Provide a short and direct response. 1.06. What is the ratio of the Gross intake ratio(%) in Italy in 2004 to that in 2006?
Give a very brief answer. 0.99. What is the ratio of the Gross intake ratio(%) in Kuwait in 2004 to that in 2006?
Ensure brevity in your answer.  1.07. What is the ratio of the Gross intake ratio(%) of Middle East & North Africa (developing only) in 2004 to that in 2007?
Your response must be concise. 0.96. What is the ratio of the Gross intake ratio(%) in Israel in 2004 to that in 2007?
Your answer should be compact. 1. What is the ratio of the Gross intake ratio(%) of Italy in 2004 to that in 2007?
Make the answer very short. 0.97. What is the ratio of the Gross intake ratio(%) of Kuwait in 2004 to that in 2007?
Ensure brevity in your answer.  1.1. What is the ratio of the Gross intake ratio(%) in Middle East & North Africa (developing only) in 2005 to that in 2006?
Make the answer very short. 0.99. What is the ratio of the Gross intake ratio(%) in Israel in 2005 to that in 2006?
Your answer should be very brief. 1.01. What is the ratio of the Gross intake ratio(%) of Italy in 2005 to that in 2006?
Your answer should be very brief. 0.98. What is the ratio of the Gross intake ratio(%) in Kuwait in 2005 to that in 2006?
Offer a very short reply. 1.01. What is the ratio of the Gross intake ratio(%) in Middle East & North Africa (developing only) in 2005 to that in 2007?
Keep it short and to the point. 0.98. What is the ratio of the Gross intake ratio(%) of Israel in 2005 to that in 2007?
Offer a very short reply. 0.96. What is the ratio of the Gross intake ratio(%) of Italy in 2005 to that in 2007?
Your response must be concise. 0.97. What is the ratio of the Gross intake ratio(%) in Kuwait in 2005 to that in 2007?
Provide a succinct answer. 1.03. What is the ratio of the Gross intake ratio(%) in Middle East & North Africa (developing only) in 2006 to that in 2007?
Your answer should be very brief. 0.99. What is the ratio of the Gross intake ratio(%) in Israel in 2006 to that in 2007?
Provide a short and direct response. 0.95. What is the ratio of the Gross intake ratio(%) in Italy in 2006 to that in 2007?
Your answer should be very brief. 0.99. What is the ratio of the Gross intake ratio(%) in Kuwait in 2006 to that in 2007?
Ensure brevity in your answer.  1.02. What is the difference between the highest and the second highest Gross intake ratio(%) in Middle East & North Africa (developing only)?
Make the answer very short. 1.26. What is the difference between the highest and the second highest Gross intake ratio(%) of Israel?
Offer a very short reply. 0.47. What is the difference between the highest and the second highest Gross intake ratio(%) in Italy?
Provide a short and direct response. 1.37. What is the difference between the highest and the second highest Gross intake ratio(%) of Kuwait?
Offer a terse response. 1.83. What is the difference between the highest and the lowest Gross intake ratio(%) in Middle East & North Africa (developing only)?
Your response must be concise. 8.29. What is the difference between the highest and the lowest Gross intake ratio(%) of Israel?
Make the answer very short. 5.87. What is the difference between the highest and the lowest Gross intake ratio(%) in Italy?
Offer a very short reply. 11.36. What is the difference between the highest and the lowest Gross intake ratio(%) in Kuwait?
Offer a terse response. 16.18. 